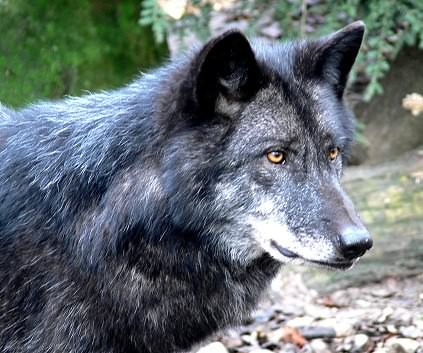Can you tell me more about the habitat preferences of the animal shown? Certainly! The wolf typically inhabits diverse regions ranging from the remote wilderness of forests and tundra to mountainous landscapes. They're highly adaptive but prefer areas with ample cover and abundant prey like deer, which provide camouflage and food sources necessary for their survival and hunting strategies. How does the wolf's physical appearance benefit its survival? The wolf's thick fur coat protects it from cold temperatures, a critical adaptation for surviving in harsh climates. Its sharp ears enhance auditory perception, crucial for detecting prey and communicating with pack members. The dark and light patches of fur provide camouflage in wooded and snowy environments, aiding in stealth during hunts. 